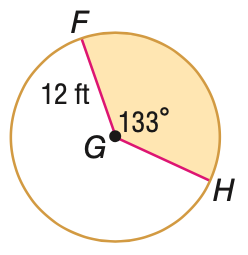Question: Find the area of the shaded sector. Round to the nearest tenth, if necessary.
Choices:
A. 47.5
B. 167.1
C. 285.3
D. 452.4
Answer with the letter. Answer: B 